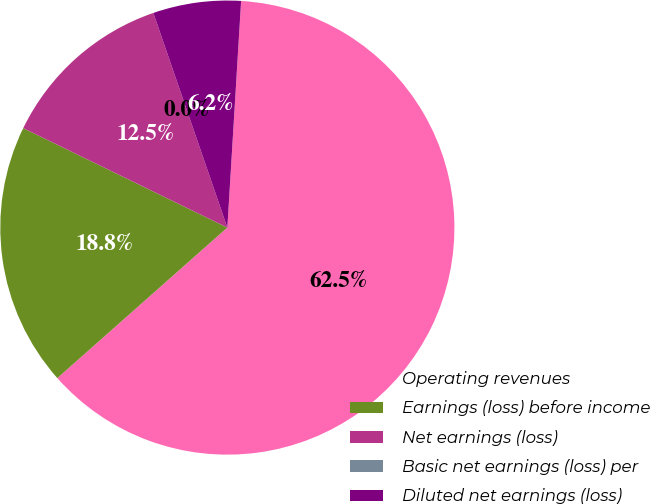Convert chart. <chart><loc_0><loc_0><loc_500><loc_500><pie_chart><fcel>Operating revenues<fcel>Earnings (loss) before income<fcel>Net earnings (loss)<fcel>Basic net earnings (loss) per<fcel>Diluted net earnings (loss)<nl><fcel>62.5%<fcel>18.75%<fcel>12.5%<fcel>0.0%<fcel>6.25%<nl></chart> 